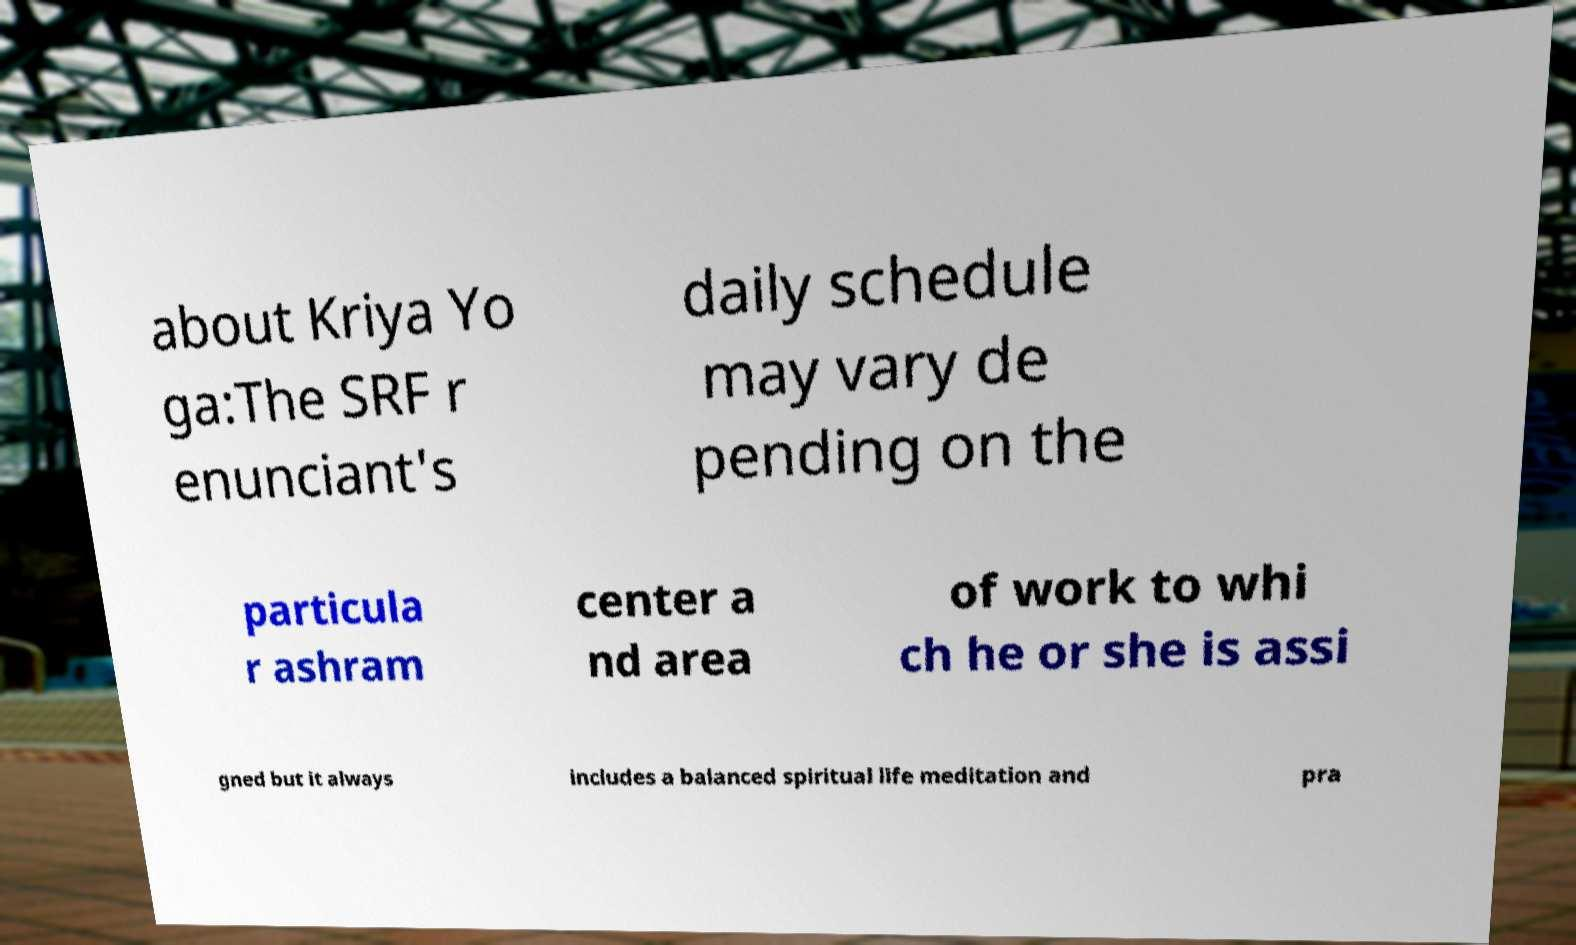Could you assist in decoding the text presented in this image and type it out clearly? about Kriya Yo ga:The SRF r enunciant's daily schedule may vary de pending on the particula r ashram center a nd area of work to whi ch he or she is assi gned but it always includes a balanced spiritual life meditation and pra 